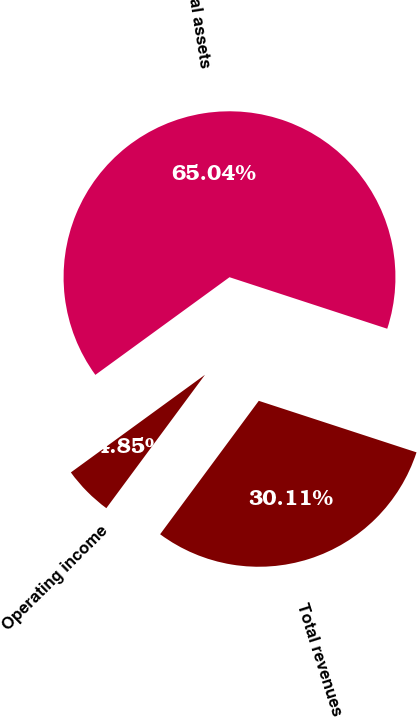Convert chart. <chart><loc_0><loc_0><loc_500><loc_500><pie_chart><fcel>Total revenues (1)<fcel>Operating income<fcel>Total assets<nl><fcel>30.11%<fcel>4.85%<fcel>65.04%<nl></chart> 